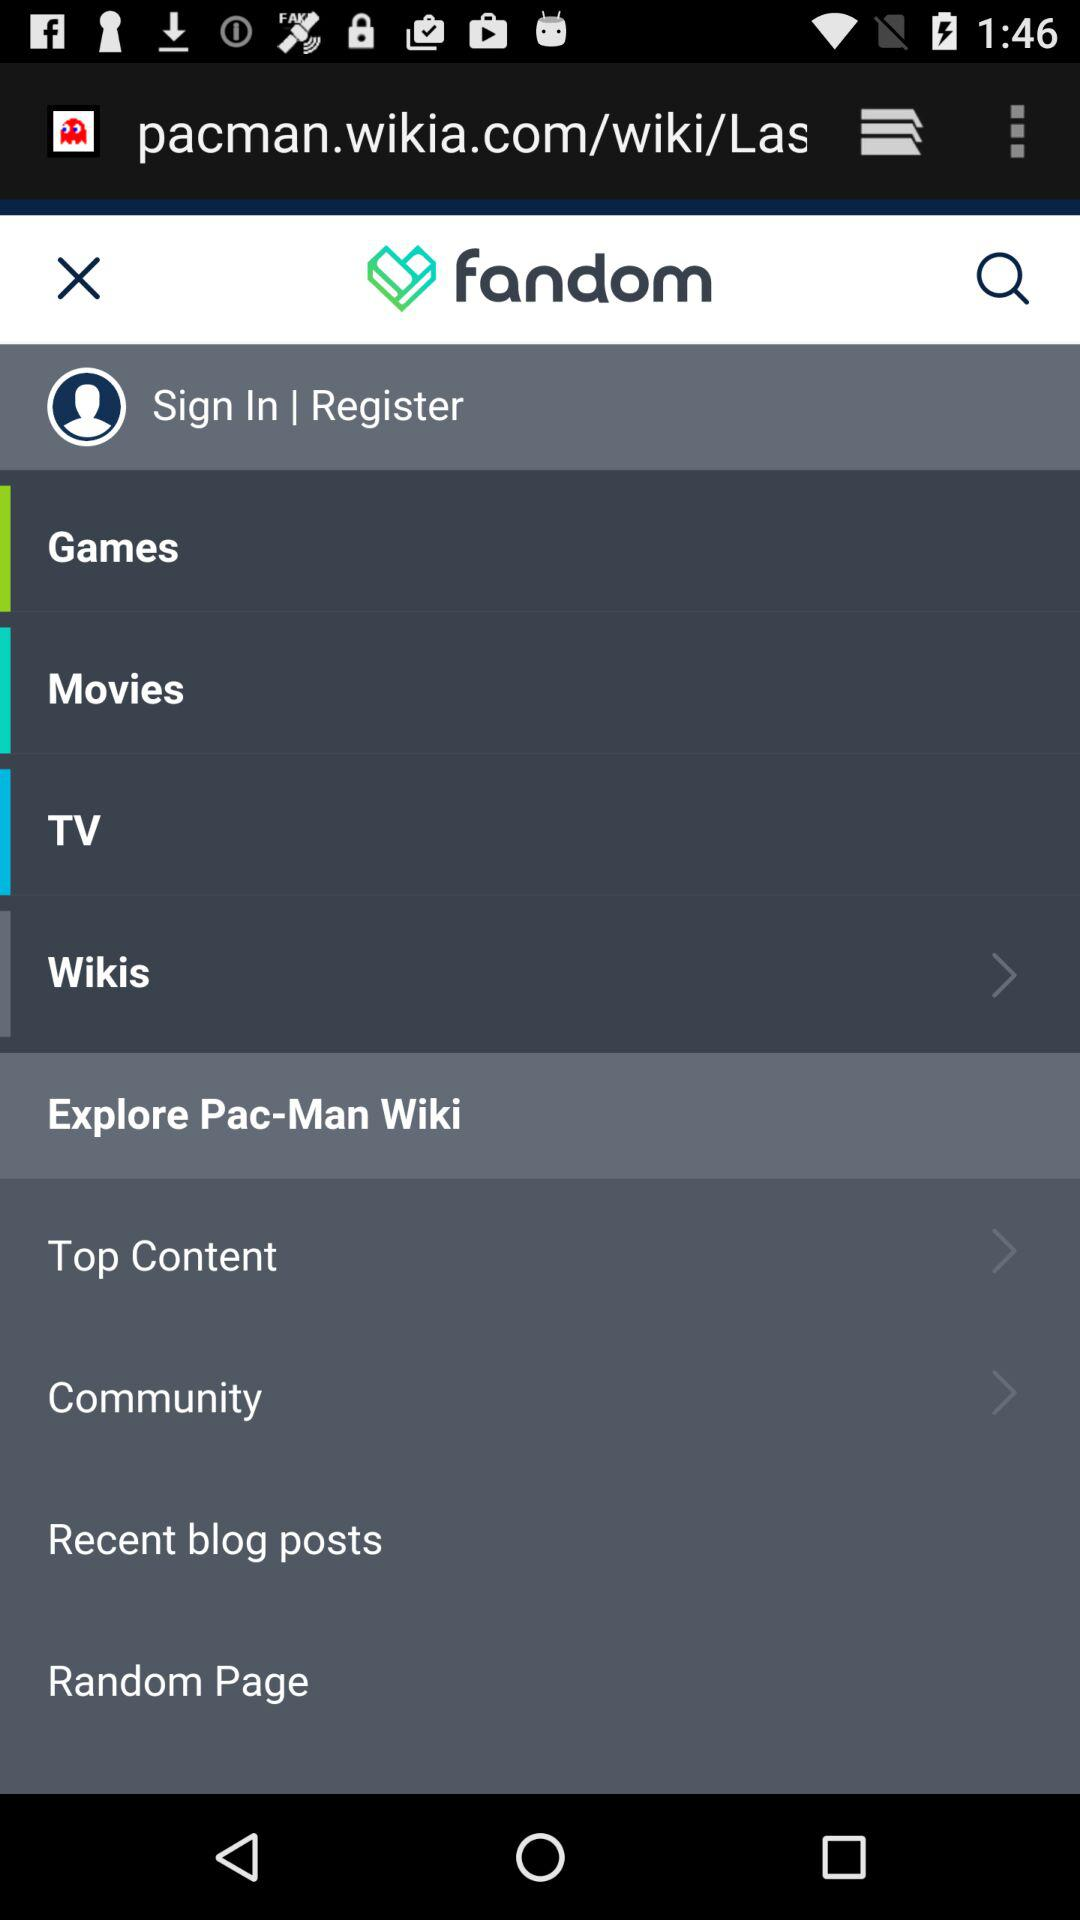What is the name of the application? The name of the application is "fandom". 